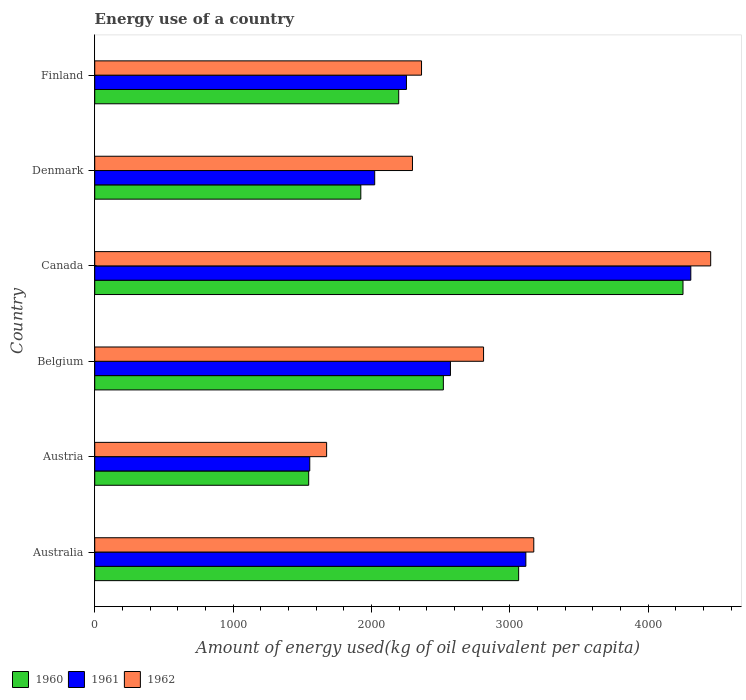How many bars are there on the 4th tick from the top?
Keep it short and to the point. 3. How many bars are there on the 2nd tick from the bottom?
Give a very brief answer. 3. What is the amount of energy used in in 1960 in Canada?
Your answer should be compact. 4251.44. Across all countries, what is the maximum amount of energy used in in 1962?
Offer a terse response. 4451.56. Across all countries, what is the minimum amount of energy used in in 1961?
Provide a succinct answer. 1554.03. In which country was the amount of energy used in in 1962 maximum?
Ensure brevity in your answer.  Canada. In which country was the amount of energy used in in 1961 minimum?
Provide a succinct answer. Austria. What is the total amount of energy used in in 1960 in the graph?
Make the answer very short. 1.55e+04. What is the difference between the amount of energy used in in 1960 in Belgium and that in Finland?
Offer a very short reply. 322.54. What is the difference between the amount of energy used in in 1960 in Canada and the amount of energy used in in 1962 in Australia?
Provide a short and direct response. 1078.46. What is the average amount of energy used in in 1962 per country?
Your answer should be very brief. 2794.75. What is the difference between the amount of energy used in in 1960 and amount of energy used in in 1961 in Australia?
Offer a terse response. -52.23. What is the ratio of the amount of energy used in in 1961 in Canada to that in Finland?
Offer a very short reply. 1.91. Is the amount of energy used in in 1962 in Belgium less than that in Finland?
Ensure brevity in your answer.  No. What is the difference between the highest and the second highest amount of energy used in in 1962?
Provide a succinct answer. 1278.59. What is the difference between the highest and the lowest amount of energy used in in 1962?
Ensure brevity in your answer.  2775.69. In how many countries, is the amount of energy used in in 1962 greater than the average amount of energy used in in 1962 taken over all countries?
Keep it short and to the point. 3. Are the values on the major ticks of X-axis written in scientific E-notation?
Ensure brevity in your answer.  No. Does the graph contain any zero values?
Offer a terse response. No. Does the graph contain grids?
Provide a succinct answer. No. How many legend labels are there?
Give a very brief answer. 3. What is the title of the graph?
Offer a terse response. Energy use of a country. What is the label or title of the X-axis?
Your answer should be very brief. Amount of energy used(kg of oil equivalent per capita). What is the label or title of the Y-axis?
Your response must be concise. Country. What is the Amount of energy used(kg of oil equivalent per capita) in 1960 in Australia?
Give a very brief answer. 3063.55. What is the Amount of energy used(kg of oil equivalent per capita) of 1961 in Australia?
Keep it short and to the point. 3115.79. What is the Amount of energy used(kg of oil equivalent per capita) in 1962 in Australia?
Ensure brevity in your answer.  3172.97. What is the Amount of energy used(kg of oil equivalent per capita) in 1960 in Austria?
Make the answer very short. 1546.26. What is the Amount of energy used(kg of oil equivalent per capita) in 1961 in Austria?
Offer a terse response. 1554.03. What is the Amount of energy used(kg of oil equivalent per capita) of 1962 in Austria?
Give a very brief answer. 1675.87. What is the Amount of energy used(kg of oil equivalent per capita) of 1960 in Belgium?
Offer a very short reply. 2519.5. What is the Amount of energy used(kg of oil equivalent per capita) in 1961 in Belgium?
Make the answer very short. 2570.82. What is the Amount of energy used(kg of oil equivalent per capita) in 1962 in Belgium?
Offer a very short reply. 2810.06. What is the Amount of energy used(kg of oil equivalent per capita) of 1960 in Canada?
Keep it short and to the point. 4251.44. What is the Amount of energy used(kg of oil equivalent per capita) of 1961 in Canada?
Offer a very short reply. 4307.82. What is the Amount of energy used(kg of oil equivalent per capita) of 1962 in Canada?
Make the answer very short. 4451.56. What is the Amount of energy used(kg of oil equivalent per capita) of 1960 in Denmark?
Your response must be concise. 1922.97. What is the Amount of energy used(kg of oil equivalent per capita) of 1961 in Denmark?
Your answer should be compact. 2023.31. What is the Amount of energy used(kg of oil equivalent per capita) of 1962 in Denmark?
Offer a terse response. 2296.29. What is the Amount of energy used(kg of oil equivalent per capita) of 1960 in Finland?
Make the answer very short. 2196.95. What is the Amount of energy used(kg of oil equivalent per capita) in 1961 in Finland?
Your answer should be very brief. 2252.78. What is the Amount of energy used(kg of oil equivalent per capita) in 1962 in Finland?
Your response must be concise. 2361.74. Across all countries, what is the maximum Amount of energy used(kg of oil equivalent per capita) of 1960?
Your response must be concise. 4251.44. Across all countries, what is the maximum Amount of energy used(kg of oil equivalent per capita) in 1961?
Make the answer very short. 4307.82. Across all countries, what is the maximum Amount of energy used(kg of oil equivalent per capita) of 1962?
Give a very brief answer. 4451.56. Across all countries, what is the minimum Amount of energy used(kg of oil equivalent per capita) of 1960?
Keep it short and to the point. 1546.26. Across all countries, what is the minimum Amount of energy used(kg of oil equivalent per capita) of 1961?
Your answer should be compact. 1554.03. Across all countries, what is the minimum Amount of energy used(kg of oil equivalent per capita) in 1962?
Your answer should be compact. 1675.87. What is the total Amount of energy used(kg of oil equivalent per capita) in 1960 in the graph?
Ensure brevity in your answer.  1.55e+04. What is the total Amount of energy used(kg of oil equivalent per capita) of 1961 in the graph?
Your answer should be compact. 1.58e+04. What is the total Amount of energy used(kg of oil equivalent per capita) in 1962 in the graph?
Give a very brief answer. 1.68e+04. What is the difference between the Amount of energy used(kg of oil equivalent per capita) of 1960 in Australia and that in Austria?
Offer a terse response. 1517.29. What is the difference between the Amount of energy used(kg of oil equivalent per capita) in 1961 in Australia and that in Austria?
Ensure brevity in your answer.  1561.75. What is the difference between the Amount of energy used(kg of oil equivalent per capita) in 1962 in Australia and that in Austria?
Ensure brevity in your answer.  1497.1. What is the difference between the Amount of energy used(kg of oil equivalent per capita) of 1960 in Australia and that in Belgium?
Offer a very short reply. 544.06. What is the difference between the Amount of energy used(kg of oil equivalent per capita) of 1961 in Australia and that in Belgium?
Offer a terse response. 544.97. What is the difference between the Amount of energy used(kg of oil equivalent per capita) of 1962 in Australia and that in Belgium?
Provide a short and direct response. 362.91. What is the difference between the Amount of energy used(kg of oil equivalent per capita) of 1960 in Australia and that in Canada?
Ensure brevity in your answer.  -1187.88. What is the difference between the Amount of energy used(kg of oil equivalent per capita) of 1961 in Australia and that in Canada?
Offer a terse response. -1192.03. What is the difference between the Amount of energy used(kg of oil equivalent per capita) of 1962 in Australia and that in Canada?
Your answer should be compact. -1278.59. What is the difference between the Amount of energy used(kg of oil equivalent per capita) of 1960 in Australia and that in Denmark?
Make the answer very short. 1140.58. What is the difference between the Amount of energy used(kg of oil equivalent per capita) in 1961 in Australia and that in Denmark?
Your answer should be very brief. 1092.48. What is the difference between the Amount of energy used(kg of oil equivalent per capita) of 1962 in Australia and that in Denmark?
Keep it short and to the point. 876.69. What is the difference between the Amount of energy used(kg of oil equivalent per capita) of 1960 in Australia and that in Finland?
Provide a succinct answer. 866.6. What is the difference between the Amount of energy used(kg of oil equivalent per capita) of 1961 in Australia and that in Finland?
Your answer should be compact. 863.01. What is the difference between the Amount of energy used(kg of oil equivalent per capita) of 1962 in Australia and that in Finland?
Keep it short and to the point. 811.23. What is the difference between the Amount of energy used(kg of oil equivalent per capita) in 1960 in Austria and that in Belgium?
Give a very brief answer. -973.24. What is the difference between the Amount of energy used(kg of oil equivalent per capita) in 1961 in Austria and that in Belgium?
Provide a short and direct response. -1016.78. What is the difference between the Amount of energy used(kg of oil equivalent per capita) in 1962 in Austria and that in Belgium?
Provide a succinct answer. -1134.19. What is the difference between the Amount of energy used(kg of oil equivalent per capita) in 1960 in Austria and that in Canada?
Give a very brief answer. -2705.17. What is the difference between the Amount of energy used(kg of oil equivalent per capita) in 1961 in Austria and that in Canada?
Your answer should be compact. -2753.79. What is the difference between the Amount of energy used(kg of oil equivalent per capita) of 1962 in Austria and that in Canada?
Keep it short and to the point. -2775.69. What is the difference between the Amount of energy used(kg of oil equivalent per capita) of 1960 in Austria and that in Denmark?
Offer a terse response. -376.71. What is the difference between the Amount of energy used(kg of oil equivalent per capita) in 1961 in Austria and that in Denmark?
Your answer should be very brief. -469.27. What is the difference between the Amount of energy used(kg of oil equivalent per capita) in 1962 in Austria and that in Denmark?
Ensure brevity in your answer.  -620.42. What is the difference between the Amount of energy used(kg of oil equivalent per capita) in 1960 in Austria and that in Finland?
Ensure brevity in your answer.  -650.69. What is the difference between the Amount of energy used(kg of oil equivalent per capita) of 1961 in Austria and that in Finland?
Your response must be concise. -698.74. What is the difference between the Amount of energy used(kg of oil equivalent per capita) of 1962 in Austria and that in Finland?
Your answer should be compact. -685.87. What is the difference between the Amount of energy used(kg of oil equivalent per capita) in 1960 in Belgium and that in Canada?
Your response must be concise. -1731.94. What is the difference between the Amount of energy used(kg of oil equivalent per capita) of 1961 in Belgium and that in Canada?
Ensure brevity in your answer.  -1737.01. What is the difference between the Amount of energy used(kg of oil equivalent per capita) in 1962 in Belgium and that in Canada?
Keep it short and to the point. -1641.5. What is the difference between the Amount of energy used(kg of oil equivalent per capita) of 1960 in Belgium and that in Denmark?
Your response must be concise. 596.52. What is the difference between the Amount of energy used(kg of oil equivalent per capita) in 1961 in Belgium and that in Denmark?
Your response must be concise. 547.51. What is the difference between the Amount of energy used(kg of oil equivalent per capita) of 1962 in Belgium and that in Denmark?
Offer a very short reply. 513.77. What is the difference between the Amount of energy used(kg of oil equivalent per capita) in 1960 in Belgium and that in Finland?
Offer a terse response. 322.54. What is the difference between the Amount of energy used(kg of oil equivalent per capita) of 1961 in Belgium and that in Finland?
Provide a short and direct response. 318.04. What is the difference between the Amount of energy used(kg of oil equivalent per capita) of 1962 in Belgium and that in Finland?
Your answer should be compact. 448.32. What is the difference between the Amount of energy used(kg of oil equivalent per capita) in 1960 in Canada and that in Denmark?
Your answer should be very brief. 2328.46. What is the difference between the Amount of energy used(kg of oil equivalent per capita) of 1961 in Canada and that in Denmark?
Provide a succinct answer. 2284.51. What is the difference between the Amount of energy used(kg of oil equivalent per capita) in 1962 in Canada and that in Denmark?
Ensure brevity in your answer.  2155.27. What is the difference between the Amount of energy used(kg of oil equivalent per capita) of 1960 in Canada and that in Finland?
Make the answer very short. 2054.48. What is the difference between the Amount of energy used(kg of oil equivalent per capita) in 1961 in Canada and that in Finland?
Your answer should be compact. 2055.04. What is the difference between the Amount of energy used(kg of oil equivalent per capita) of 1962 in Canada and that in Finland?
Give a very brief answer. 2089.82. What is the difference between the Amount of energy used(kg of oil equivalent per capita) in 1960 in Denmark and that in Finland?
Provide a succinct answer. -273.98. What is the difference between the Amount of energy used(kg of oil equivalent per capita) of 1961 in Denmark and that in Finland?
Provide a succinct answer. -229.47. What is the difference between the Amount of energy used(kg of oil equivalent per capita) in 1962 in Denmark and that in Finland?
Keep it short and to the point. -65.45. What is the difference between the Amount of energy used(kg of oil equivalent per capita) of 1960 in Australia and the Amount of energy used(kg of oil equivalent per capita) of 1961 in Austria?
Offer a very short reply. 1509.52. What is the difference between the Amount of energy used(kg of oil equivalent per capita) in 1960 in Australia and the Amount of energy used(kg of oil equivalent per capita) in 1962 in Austria?
Give a very brief answer. 1387.68. What is the difference between the Amount of energy used(kg of oil equivalent per capita) in 1961 in Australia and the Amount of energy used(kg of oil equivalent per capita) in 1962 in Austria?
Keep it short and to the point. 1439.91. What is the difference between the Amount of energy used(kg of oil equivalent per capita) in 1960 in Australia and the Amount of energy used(kg of oil equivalent per capita) in 1961 in Belgium?
Your answer should be very brief. 492.74. What is the difference between the Amount of energy used(kg of oil equivalent per capita) of 1960 in Australia and the Amount of energy used(kg of oil equivalent per capita) of 1962 in Belgium?
Ensure brevity in your answer.  253.49. What is the difference between the Amount of energy used(kg of oil equivalent per capita) of 1961 in Australia and the Amount of energy used(kg of oil equivalent per capita) of 1962 in Belgium?
Offer a very short reply. 305.73. What is the difference between the Amount of energy used(kg of oil equivalent per capita) in 1960 in Australia and the Amount of energy used(kg of oil equivalent per capita) in 1961 in Canada?
Your response must be concise. -1244.27. What is the difference between the Amount of energy used(kg of oil equivalent per capita) of 1960 in Australia and the Amount of energy used(kg of oil equivalent per capita) of 1962 in Canada?
Keep it short and to the point. -1388.01. What is the difference between the Amount of energy used(kg of oil equivalent per capita) in 1961 in Australia and the Amount of energy used(kg of oil equivalent per capita) in 1962 in Canada?
Make the answer very short. -1335.77. What is the difference between the Amount of energy used(kg of oil equivalent per capita) of 1960 in Australia and the Amount of energy used(kg of oil equivalent per capita) of 1961 in Denmark?
Provide a short and direct response. 1040.25. What is the difference between the Amount of energy used(kg of oil equivalent per capita) in 1960 in Australia and the Amount of energy used(kg of oil equivalent per capita) in 1962 in Denmark?
Your answer should be very brief. 767.26. What is the difference between the Amount of energy used(kg of oil equivalent per capita) in 1961 in Australia and the Amount of energy used(kg of oil equivalent per capita) in 1962 in Denmark?
Keep it short and to the point. 819.5. What is the difference between the Amount of energy used(kg of oil equivalent per capita) in 1960 in Australia and the Amount of energy used(kg of oil equivalent per capita) in 1961 in Finland?
Provide a succinct answer. 810.78. What is the difference between the Amount of energy used(kg of oil equivalent per capita) in 1960 in Australia and the Amount of energy used(kg of oil equivalent per capita) in 1962 in Finland?
Your answer should be compact. 701.81. What is the difference between the Amount of energy used(kg of oil equivalent per capita) of 1961 in Australia and the Amount of energy used(kg of oil equivalent per capita) of 1962 in Finland?
Provide a short and direct response. 754.04. What is the difference between the Amount of energy used(kg of oil equivalent per capita) in 1960 in Austria and the Amount of energy used(kg of oil equivalent per capita) in 1961 in Belgium?
Keep it short and to the point. -1024.55. What is the difference between the Amount of energy used(kg of oil equivalent per capita) in 1960 in Austria and the Amount of energy used(kg of oil equivalent per capita) in 1962 in Belgium?
Offer a terse response. -1263.8. What is the difference between the Amount of energy used(kg of oil equivalent per capita) in 1961 in Austria and the Amount of energy used(kg of oil equivalent per capita) in 1962 in Belgium?
Your answer should be very brief. -1256.03. What is the difference between the Amount of energy used(kg of oil equivalent per capita) of 1960 in Austria and the Amount of energy used(kg of oil equivalent per capita) of 1961 in Canada?
Provide a succinct answer. -2761.56. What is the difference between the Amount of energy used(kg of oil equivalent per capita) in 1960 in Austria and the Amount of energy used(kg of oil equivalent per capita) in 1962 in Canada?
Ensure brevity in your answer.  -2905.3. What is the difference between the Amount of energy used(kg of oil equivalent per capita) of 1961 in Austria and the Amount of energy used(kg of oil equivalent per capita) of 1962 in Canada?
Ensure brevity in your answer.  -2897.53. What is the difference between the Amount of energy used(kg of oil equivalent per capita) in 1960 in Austria and the Amount of energy used(kg of oil equivalent per capita) in 1961 in Denmark?
Make the answer very short. -477.05. What is the difference between the Amount of energy used(kg of oil equivalent per capita) of 1960 in Austria and the Amount of energy used(kg of oil equivalent per capita) of 1962 in Denmark?
Provide a short and direct response. -750.03. What is the difference between the Amount of energy used(kg of oil equivalent per capita) of 1961 in Austria and the Amount of energy used(kg of oil equivalent per capita) of 1962 in Denmark?
Keep it short and to the point. -742.25. What is the difference between the Amount of energy used(kg of oil equivalent per capita) of 1960 in Austria and the Amount of energy used(kg of oil equivalent per capita) of 1961 in Finland?
Make the answer very short. -706.52. What is the difference between the Amount of energy used(kg of oil equivalent per capita) in 1960 in Austria and the Amount of energy used(kg of oil equivalent per capita) in 1962 in Finland?
Offer a terse response. -815.48. What is the difference between the Amount of energy used(kg of oil equivalent per capita) of 1961 in Austria and the Amount of energy used(kg of oil equivalent per capita) of 1962 in Finland?
Your answer should be very brief. -807.71. What is the difference between the Amount of energy used(kg of oil equivalent per capita) of 1960 in Belgium and the Amount of energy used(kg of oil equivalent per capita) of 1961 in Canada?
Give a very brief answer. -1788.32. What is the difference between the Amount of energy used(kg of oil equivalent per capita) in 1960 in Belgium and the Amount of energy used(kg of oil equivalent per capita) in 1962 in Canada?
Offer a very short reply. -1932.06. What is the difference between the Amount of energy used(kg of oil equivalent per capita) in 1961 in Belgium and the Amount of energy used(kg of oil equivalent per capita) in 1962 in Canada?
Your response must be concise. -1880.74. What is the difference between the Amount of energy used(kg of oil equivalent per capita) in 1960 in Belgium and the Amount of energy used(kg of oil equivalent per capita) in 1961 in Denmark?
Provide a short and direct response. 496.19. What is the difference between the Amount of energy used(kg of oil equivalent per capita) in 1960 in Belgium and the Amount of energy used(kg of oil equivalent per capita) in 1962 in Denmark?
Ensure brevity in your answer.  223.21. What is the difference between the Amount of energy used(kg of oil equivalent per capita) in 1961 in Belgium and the Amount of energy used(kg of oil equivalent per capita) in 1962 in Denmark?
Give a very brief answer. 274.53. What is the difference between the Amount of energy used(kg of oil equivalent per capita) in 1960 in Belgium and the Amount of energy used(kg of oil equivalent per capita) in 1961 in Finland?
Give a very brief answer. 266.72. What is the difference between the Amount of energy used(kg of oil equivalent per capita) of 1960 in Belgium and the Amount of energy used(kg of oil equivalent per capita) of 1962 in Finland?
Give a very brief answer. 157.75. What is the difference between the Amount of energy used(kg of oil equivalent per capita) in 1961 in Belgium and the Amount of energy used(kg of oil equivalent per capita) in 1962 in Finland?
Give a very brief answer. 209.07. What is the difference between the Amount of energy used(kg of oil equivalent per capita) of 1960 in Canada and the Amount of energy used(kg of oil equivalent per capita) of 1961 in Denmark?
Give a very brief answer. 2228.13. What is the difference between the Amount of energy used(kg of oil equivalent per capita) of 1960 in Canada and the Amount of energy used(kg of oil equivalent per capita) of 1962 in Denmark?
Give a very brief answer. 1955.15. What is the difference between the Amount of energy used(kg of oil equivalent per capita) in 1961 in Canada and the Amount of energy used(kg of oil equivalent per capita) in 1962 in Denmark?
Offer a very short reply. 2011.53. What is the difference between the Amount of energy used(kg of oil equivalent per capita) of 1960 in Canada and the Amount of energy used(kg of oil equivalent per capita) of 1961 in Finland?
Offer a terse response. 1998.66. What is the difference between the Amount of energy used(kg of oil equivalent per capita) of 1960 in Canada and the Amount of energy used(kg of oil equivalent per capita) of 1962 in Finland?
Keep it short and to the point. 1889.69. What is the difference between the Amount of energy used(kg of oil equivalent per capita) of 1961 in Canada and the Amount of energy used(kg of oil equivalent per capita) of 1962 in Finland?
Give a very brief answer. 1946.08. What is the difference between the Amount of energy used(kg of oil equivalent per capita) of 1960 in Denmark and the Amount of energy used(kg of oil equivalent per capita) of 1961 in Finland?
Your response must be concise. -329.81. What is the difference between the Amount of energy used(kg of oil equivalent per capita) in 1960 in Denmark and the Amount of energy used(kg of oil equivalent per capita) in 1962 in Finland?
Keep it short and to the point. -438.77. What is the difference between the Amount of energy used(kg of oil equivalent per capita) of 1961 in Denmark and the Amount of energy used(kg of oil equivalent per capita) of 1962 in Finland?
Make the answer very short. -338.44. What is the average Amount of energy used(kg of oil equivalent per capita) of 1960 per country?
Provide a succinct answer. 2583.45. What is the average Amount of energy used(kg of oil equivalent per capita) in 1961 per country?
Ensure brevity in your answer.  2637.42. What is the average Amount of energy used(kg of oil equivalent per capita) of 1962 per country?
Make the answer very short. 2794.75. What is the difference between the Amount of energy used(kg of oil equivalent per capita) in 1960 and Amount of energy used(kg of oil equivalent per capita) in 1961 in Australia?
Your answer should be compact. -52.23. What is the difference between the Amount of energy used(kg of oil equivalent per capita) of 1960 and Amount of energy used(kg of oil equivalent per capita) of 1962 in Australia?
Keep it short and to the point. -109.42. What is the difference between the Amount of energy used(kg of oil equivalent per capita) in 1961 and Amount of energy used(kg of oil equivalent per capita) in 1962 in Australia?
Your response must be concise. -57.19. What is the difference between the Amount of energy used(kg of oil equivalent per capita) of 1960 and Amount of energy used(kg of oil equivalent per capita) of 1961 in Austria?
Keep it short and to the point. -7.77. What is the difference between the Amount of energy used(kg of oil equivalent per capita) of 1960 and Amount of energy used(kg of oil equivalent per capita) of 1962 in Austria?
Your response must be concise. -129.61. What is the difference between the Amount of energy used(kg of oil equivalent per capita) in 1961 and Amount of energy used(kg of oil equivalent per capita) in 1962 in Austria?
Your answer should be compact. -121.84. What is the difference between the Amount of energy used(kg of oil equivalent per capita) of 1960 and Amount of energy used(kg of oil equivalent per capita) of 1961 in Belgium?
Your answer should be very brief. -51.32. What is the difference between the Amount of energy used(kg of oil equivalent per capita) of 1960 and Amount of energy used(kg of oil equivalent per capita) of 1962 in Belgium?
Your answer should be compact. -290.56. What is the difference between the Amount of energy used(kg of oil equivalent per capita) in 1961 and Amount of energy used(kg of oil equivalent per capita) in 1962 in Belgium?
Your answer should be compact. -239.25. What is the difference between the Amount of energy used(kg of oil equivalent per capita) of 1960 and Amount of energy used(kg of oil equivalent per capita) of 1961 in Canada?
Keep it short and to the point. -56.38. What is the difference between the Amount of energy used(kg of oil equivalent per capita) in 1960 and Amount of energy used(kg of oil equivalent per capita) in 1962 in Canada?
Offer a terse response. -200.12. What is the difference between the Amount of energy used(kg of oil equivalent per capita) in 1961 and Amount of energy used(kg of oil equivalent per capita) in 1962 in Canada?
Ensure brevity in your answer.  -143.74. What is the difference between the Amount of energy used(kg of oil equivalent per capita) of 1960 and Amount of energy used(kg of oil equivalent per capita) of 1961 in Denmark?
Make the answer very short. -100.33. What is the difference between the Amount of energy used(kg of oil equivalent per capita) of 1960 and Amount of energy used(kg of oil equivalent per capita) of 1962 in Denmark?
Your response must be concise. -373.32. What is the difference between the Amount of energy used(kg of oil equivalent per capita) in 1961 and Amount of energy used(kg of oil equivalent per capita) in 1962 in Denmark?
Give a very brief answer. -272.98. What is the difference between the Amount of energy used(kg of oil equivalent per capita) of 1960 and Amount of energy used(kg of oil equivalent per capita) of 1961 in Finland?
Offer a terse response. -55.83. What is the difference between the Amount of energy used(kg of oil equivalent per capita) in 1960 and Amount of energy used(kg of oil equivalent per capita) in 1962 in Finland?
Make the answer very short. -164.79. What is the difference between the Amount of energy used(kg of oil equivalent per capita) in 1961 and Amount of energy used(kg of oil equivalent per capita) in 1962 in Finland?
Your answer should be very brief. -108.97. What is the ratio of the Amount of energy used(kg of oil equivalent per capita) in 1960 in Australia to that in Austria?
Give a very brief answer. 1.98. What is the ratio of the Amount of energy used(kg of oil equivalent per capita) in 1961 in Australia to that in Austria?
Ensure brevity in your answer.  2. What is the ratio of the Amount of energy used(kg of oil equivalent per capita) in 1962 in Australia to that in Austria?
Make the answer very short. 1.89. What is the ratio of the Amount of energy used(kg of oil equivalent per capita) of 1960 in Australia to that in Belgium?
Provide a succinct answer. 1.22. What is the ratio of the Amount of energy used(kg of oil equivalent per capita) in 1961 in Australia to that in Belgium?
Your answer should be very brief. 1.21. What is the ratio of the Amount of energy used(kg of oil equivalent per capita) of 1962 in Australia to that in Belgium?
Give a very brief answer. 1.13. What is the ratio of the Amount of energy used(kg of oil equivalent per capita) of 1960 in Australia to that in Canada?
Provide a succinct answer. 0.72. What is the ratio of the Amount of energy used(kg of oil equivalent per capita) in 1961 in Australia to that in Canada?
Make the answer very short. 0.72. What is the ratio of the Amount of energy used(kg of oil equivalent per capita) in 1962 in Australia to that in Canada?
Offer a very short reply. 0.71. What is the ratio of the Amount of energy used(kg of oil equivalent per capita) of 1960 in Australia to that in Denmark?
Your answer should be very brief. 1.59. What is the ratio of the Amount of energy used(kg of oil equivalent per capita) of 1961 in Australia to that in Denmark?
Your answer should be compact. 1.54. What is the ratio of the Amount of energy used(kg of oil equivalent per capita) of 1962 in Australia to that in Denmark?
Offer a very short reply. 1.38. What is the ratio of the Amount of energy used(kg of oil equivalent per capita) of 1960 in Australia to that in Finland?
Offer a terse response. 1.39. What is the ratio of the Amount of energy used(kg of oil equivalent per capita) of 1961 in Australia to that in Finland?
Your answer should be compact. 1.38. What is the ratio of the Amount of energy used(kg of oil equivalent per capita) in 1962 in Australia to that in Finland?
Provide a short and direct response. 1.34. What is the ratio of the Amount of energy used(kg of oil equivalent per capita) in 1960 in Austria to that in Belgium?
Provide a short and direct response. 0.61. What is the ratio of the Amount of energy used(kg of oil equivalent per capita) of 1961 in Austria to that in Belgium?
Your answer should be compact. 0.6. What is the ratio of the Amount of energy used(kg of oil equivalent per capita) in 1962 in Austria to that in Belgium?
Provide a short and direct response. 0.6. What is the ratio of the Amount of energy used(kg of oil equivalent per capita) in 1960 in Austria to that in Canada?
Provide a succinct answer. 0.36. What is the ratio of the Amount of energy used(kg of oil equivalent per capita) of 1961 in Austria to that in Canada?
Ensure brevity in your answer.  0.36. What is the ratio of the Amount of energy used(kg of oil equivalent per capita) of 1962 in Austria to that in Canada?
Make the answer very short. 0.38. What is the ratio of the Amount of energy used(kg of oil equivalent per capita) of 1960 in Austria to that in Denmark?
Ensure brevity in your answer.  0.8. What is the ratio of the Amount of energy used(kg of oil equivalent per capita) in 1961 in Austria to that in Denmark?
Provide a succinct answer. 0.77. What is the ratio of the Amount of energy used(kg of oil equivalent per capita) of 1962 in Austria to that in Denmark?
Your answer should be very brief. 0.73. What is the ratio of the Amount of energy used(kg of oil equivalent per capita) of 1960 in Austria to that in Finland?
Your answer should be compact. 0.7. What is the ratio of the Amount of energy used(kg of oil equivalent per capita) in 1961 in Austria to that in Finland?
Ensure brevity in your answer.  0.69. What is the ratio of the Amount of energy used(kg of oil equivalent per capita) in 1962 in Austria to that in Finland?
Your answer should be compact. 0.71. What is the ratio of the Amount of energy used(kg of oil equivalent per capita) of 1960 in Belgium to that in Canada?
Make the answer very short. 0.59. What is the ratio of the Amount of energy used(kg of oil equivalent per capita) of 1961 in Belgium to that in Canada?
Offer a very short reply. 0.6. What is the ratio of the Amount of energy used(kg of oil equivalent per capita) of 1962 in Belgium to that in Canada?
Your answer should be very brief. 0.63. What is the ratio of the Amount of energy used(kg of oil equivalent per capita) in 1960 in Belgium to that in Denmark?
Your response must be concise. 1.31. What is the ratio of the Amount of energy used(kg of oil equivalent per capita) of 1961 in Belgium to that in Denmark?
Your response must be concise. 1.27. What is the ratio of the Amount of energy used(kg of oil equivalent per capita) of 1962 in Belgium to that in Denmark?
Your answer should be very brief. 1.22. What is the ratio of the Amount of energy used(kg of oil equivalent per capita) in 1960 in Belgium to that in Finland?
Keep it short and to the point. 1.15. What is the ratio of the Amount of energy used(kg of oil equivalent per capita) in 1961 in Belgium to that in Finland?
Your response must be concise. 1.14. What is the ratio of the Amount of energy used(kg of oil equivalent per capita) in 1962 in Belgium to that in Finland?
Your answer should be compact. 1.19. What is the ratio of the Amount of energy used(kg of oil equivalent per capita) of 1960 in Canada to that in Denmark?
Provide a short and direct response. 2.21. What is the ratio of the Amount of energy used(kg of oil equivalent per capita) in 1961 in Canada to that in Denmark?
Provide a short and direct response. 2.13. What is the ratio of the Amount of energy used(kg of oil equivalent per capita) of 1962 in Canada to that in Denmark?
Give a very brief answer. 1.94. What is the ratio of the Amount of energy used(kg of oil equivalent per capita) of 1960 in Canada to that in Finland?
Provide a short and direct response. 1.94. What is the ratio of the Amount of energy used(kg of oil equivalent per capita) in 1961 in Canada to that in Finland?
Give a very brief answer. 1.91. What is the ratio of the Amount of energy used(kg of oil equivalent per capita) of 1962 in Canada to that in Finland?
Offer a very short reply. 1.88. What is the ratio of the Amount of energy used(kg of oil equivalent per capita) of 1960 in Denmark to that in Finland?
Keep it short and to the point. 0.88. What is the ratio of the Amount of energy used(kg of oil equivalent per capita) of 1961 in Denmark to that in Finland?
Your answer should be compact. 0.9. What is the ratio of the Amount of energy used(kg of oil equivalent per capita) of 1962 in Denmark to that in Finland?
Provide a short and direct response. 0.97. What is the difference between the highest and the second highest Amount of energy used(kg of oil equivalent per capita) in 1960?
Your response must be concise. 1187.88. What is the difference between the highest and the second highest Amount of energy used(kg of oil equivalent per capita) of 1961?
Ensure brevity in your answer.  1192.03. What is the difference between the highest and the second highest Amount of energy used(kg of oil equivalent per capita) in 1962?
Make the answer very short. 1278.59. What is the difference between the highest and the lowest Amount of energy used(kg of oil equivalent per capita) of 1960?
Keep it short and to the point. 2705.17. What is the difference between the highest and the lowest Amount of energy used(kg of oil equivalent per capita) of 1961?
Make the answer very short. 2753.79. What is the difference between the highest and the lowest Amount of energy used(kg of oil equivalent per capita) of 1962?
Ensure brevity in your answer.  2775.69. 